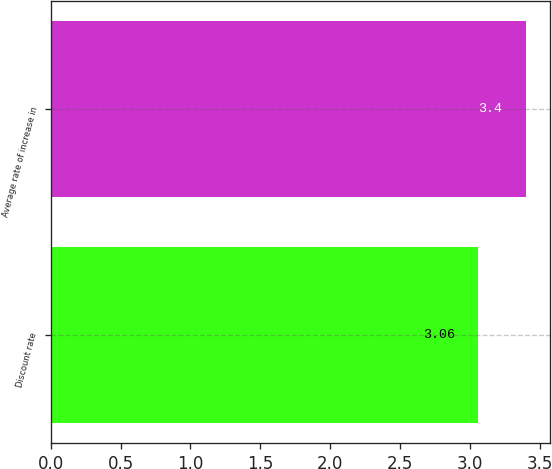Convert chart to OTSL. <chart><loc_0><loc_0><loc_500><loc_500><bar_chart><fcel>Discount rate<fcel>Average rate of increase in<nl><fcel>3.06<fcel>3.4<nl></chart> 